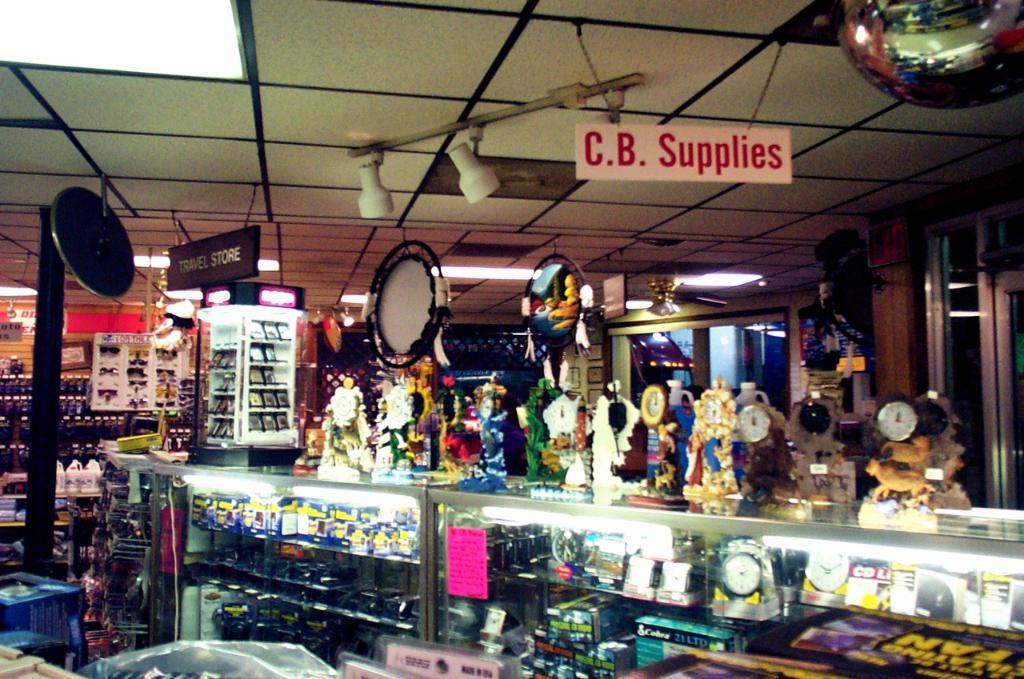<image>
Provide a brief description of the given image. Store with a sign "C.B. Supplies" hanging from the ceiling. 